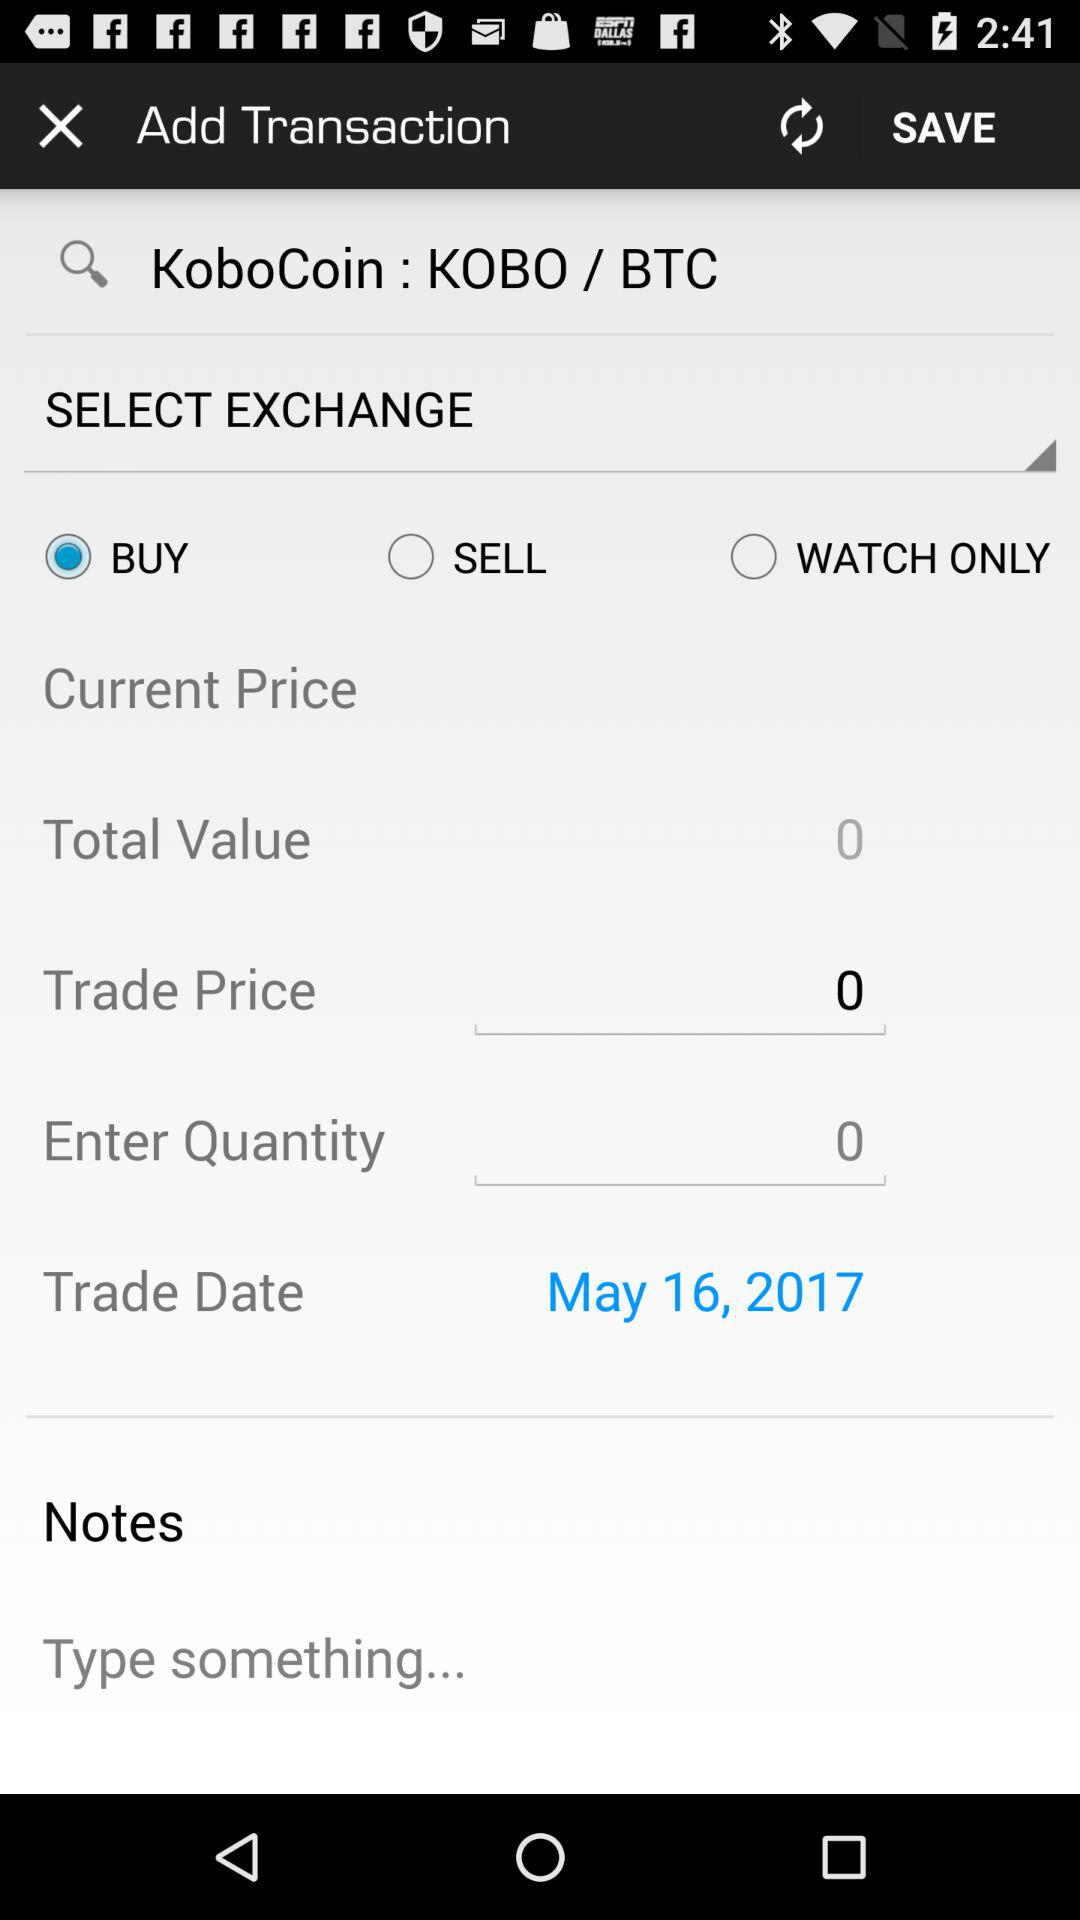What is the trade date? The trade date is May 16, 2017. 